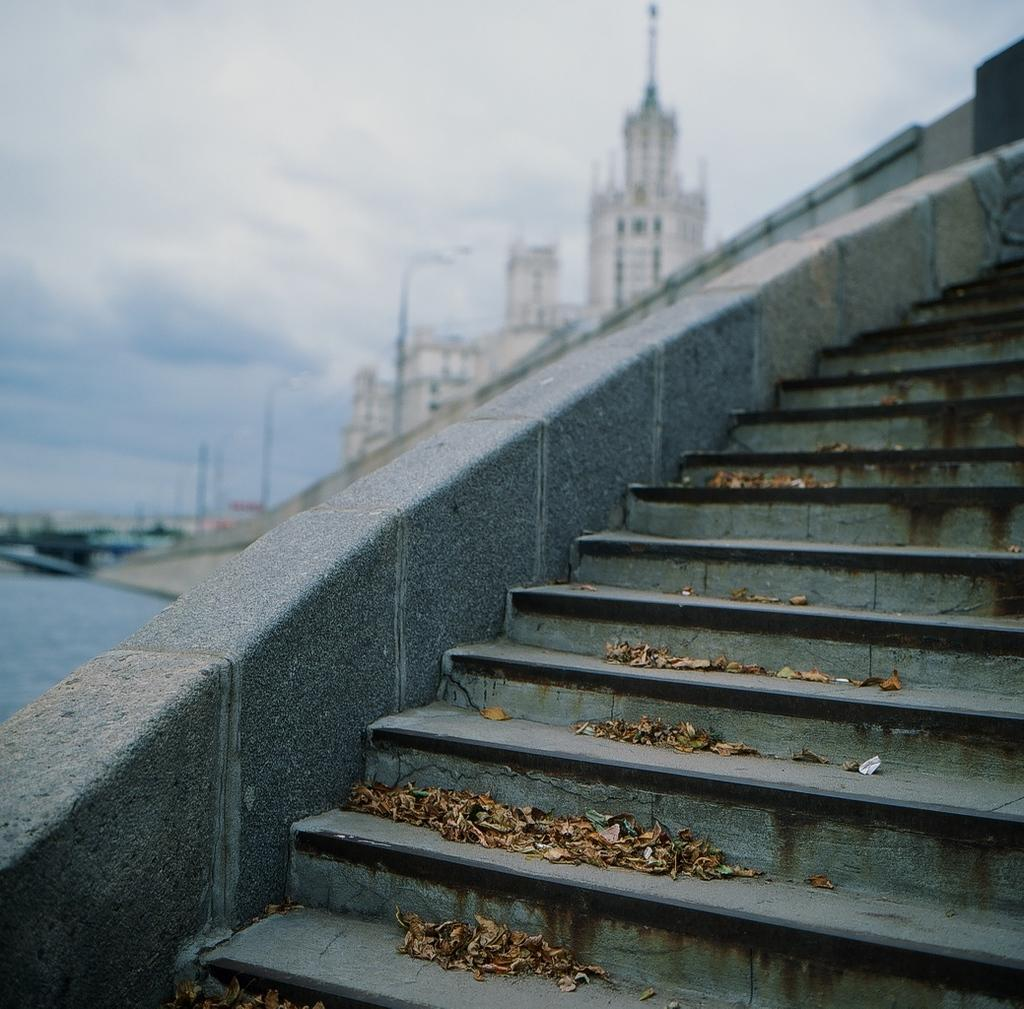What type of structure is present in the image? There are stairs in the image. What can be seen in the background of the image? There are buildings in the background of the image. What is the color of the buildings? The buildings are white in color. What other objects are present in the image? There are light poles in the image. What is visible above the buildings? The sky is visible in the image. How would you describe the color of the sky? The sky has a combination of white and blue colors. What type of plant is growing on the light poles in the image? There are no plants growing on the light poles in the image. How does the popcorn affect the appearance of the buildings in the image? There is no popcorn present in the image, so it cannot affect the appearance of the buildings. 